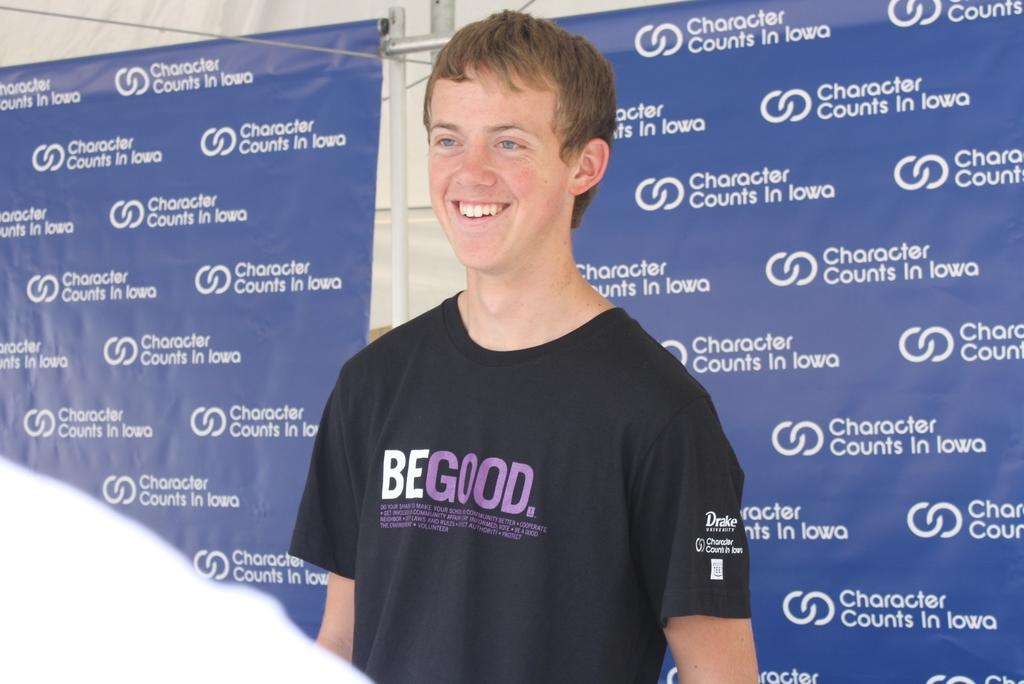<image>
Relay a brief, clear account of the picture shown. A young man smiles while wearing a Be Good t-shirt. 